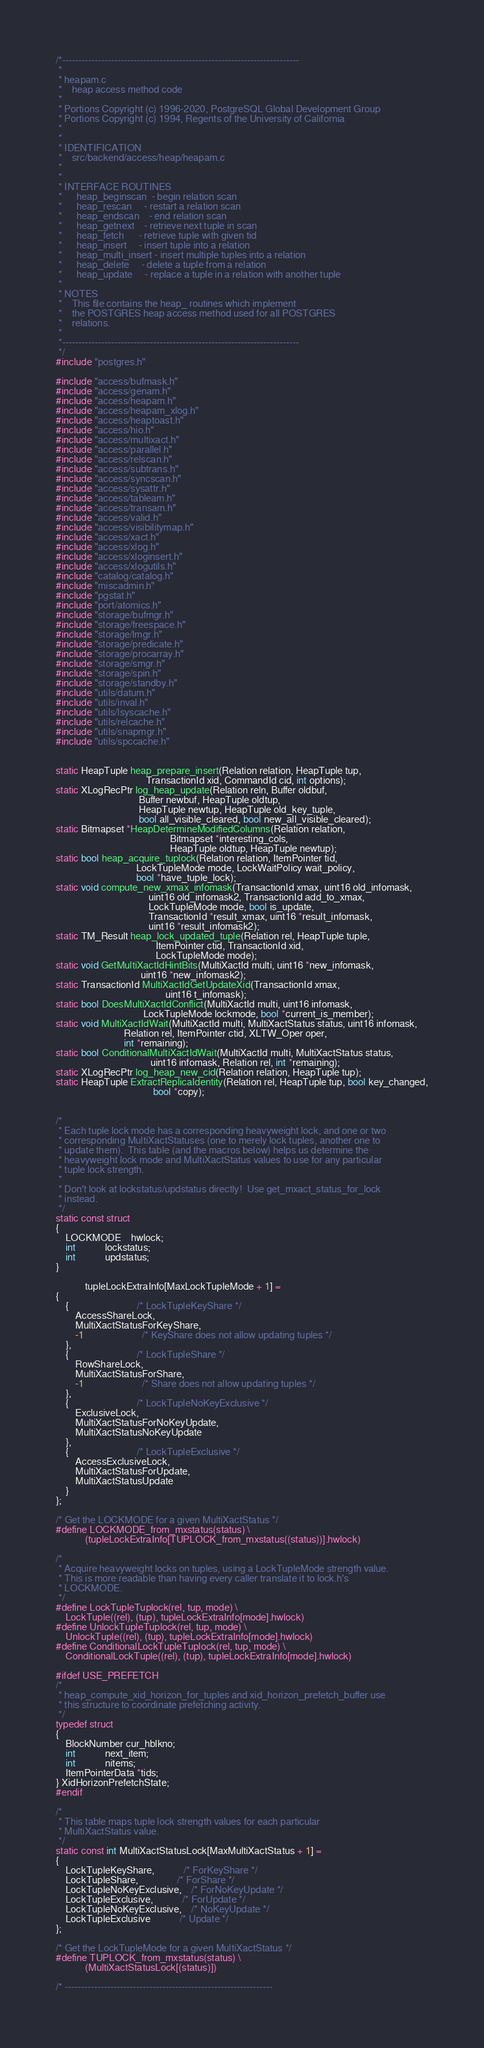<code> <loc_0><loc_0><loc_500><loc_500><_C_>/*-------------------------------------------------------------------------
 *
 * heapam.c
 *	  heap access method code
 *
 * Portions Copyright (c) 1996-2020, PostgreSQL Global Development Group
 * Portions Copyright (c) 1994, Regents of the University of California
 *
 *
 * IDENTIFICATION
 *	  src/backend/access/heap/heapam.c
 *
 *
 * INTERFACE ROUTINES
 *		heap_beginscan	- begin relation scan
 *		heap_rescan		- restart a relation scan
 *		heap_endscan	- end relation scan
 *		heap_getnext	- retrieve next tuple in scan
 *		heap_fetch		- retrieve tuple with given tid
 *		heap_insert		- insert tuple into a relation
 *		heap_multi_insert - insert multiple tuples into a relation
 *		heap_delete		- delete a tuple from a relation
 *		heap_update		- replace a tuple in a relation with another tuple
 *
 * NOTES
 *	  This file contains the heap_ routines which implement
 *	  the POSTGRES heap access method used for all POSTGRES
 *	  relations.
 *
 *-------------------------------------------------------------------------
 */
#include "postgres.h"

#include "access/bufmask.h"
#include "access/genam.h"
#include "access/heapam.h"
#include "access/heapam_xlog.h"
#include "access/heaptoast.h"
#include "access/hio.h"
#include "access/multixact.h"
#include "access/parallel.h"
#include "access/relscan.h"
#include "access/subtrans.h"
#include "access/syncscan.h"
#include "access/sysattr.h"
#include "access/tableam.h"
#include "access/transam.h"
#include "access/valid.h"
#include "access/visibilitymap.h"
#include "access/xact.h"
#include "access/xlog.h"
#include "access/xloginsert.h"
#include "access/xlogutils.h"
#include "catalog/catalog.h"
#include "miscadmin.h"
#include "pgstat.h"
#include "port/atomics.h"
#include "storage/bufmgr.h"
#include "storage/freespace.h"
#include "storage/lmgr.h"
#include "storage/predicate.h"
#include "storage/procarray.h"
#include "storage/smgr.h"
#include "storage/spin.h"
#include "storage/standby.h"
#include "utils/datum.h"
#include "utils/inval.h"
#include "utils/lsyscache.h"
#include "utils/relcache.h"
#include "utils/snapmgr.h"
#include "utils/spccache.h"


static HeapTuple heap_prepare_insert(Relation relation, HeapTuple tup,
									 TransactionId xid, CommandId cid, int options);
static XLogRecPtr log_heap_update(Relation reln, Buffer oldbuf,
								  Buffer newbuf, HeapTuple oldtup,
								  HeapTuple newtup, HeapTuple old_key_tuple,
								  bool all_visible_cleared, bool new_all_visible_cleared);
static Bitmapset *HeapDetermineModifiedColumns(Relation relation,
											   Bitmapset *interesting_cols,
											   HeapTuple oldtup, HeapTuple newtup);
static bool heap_acquire_tuplock(Relation relation, ItemPointer tid,
								 LockTupleMode mode, LockWaitPolicy wait_policy,
								 bool *have_tuple_lock);
static void compute_new_xmax_infomask(TransactionId xmax, uint16 old_infomask,
									  uint16 old_infomask2, TransactionId add_to_xmax,
									  LockTupleMode mode, bool is_update,
									  TransactionId *result_xmax, uint16 *result_infomask,
									  uint16 *result_infomask2);
static TM_Result heap_lock_updated_tuple(Relation rel, HeapTuple tuple,
										 ItemPointer ctid, TransactionId xid,
										 LockTupleMode mode);
static void GetMultiXactIdHintBits(MultiXactId multi, uint16 *new_infomask,
								   uint16 *new_infomask2);
static TransactionId MultiXactIdGetUpdateXid(TransactionId xmax,
											 uint16 t_infomask);
static bool DoesMultiXactIdConflict(MultiXactId multi, uint16 infomask,
									LockTupleMode lockmode, bool *current_is_member);
static void MultiXactIdWait(MultiXactId multi, MultiXactStatus status, uint16 infomask,
							Relation rel, ItemPointer ctid, XLTW_Oper oper,
							int *remaining);
static bool ConditionalMultiXactIdWait(MultiXactId multi, MultiXactStatus status,
									   uint16 infomask, Relation rel, int *remaining);
static XLogRecPtr log_heap_new_cid(Relation relation, HeapTuple tup);
static HeapTuple ExtractReplicaIdentity(Relation rel, HeapTuple tup, bool key_changed,
										bool *copy);


/*
 * Each tuple lock mode has a corresponding heavyweight lock, and one or two
 * corresponding MultiXactStatuses (one to merely lock tuples, another one to
 * update them).  This table (and the macros below) helps us determine the
 * heavyweight lock mode and MultiXactStatus values to use for any particular
 * tuple lock strength.
 *
 * Don't look at lockstatus/updstatus directly!  Use get_mxact_status_for_lock
 * instead.
 */
static const struct
{
	LOCKMODE	hwlock;
	int			lockstatus;
	int			updstatus;
}

			tupleLockExtraInfo[MaxLockTupleMode + 1] =
{
	{							/* LockTupleKeyShare */
		AccessShareLock,
		MultiXactStatusForKeyShare,
		-1						/* KeyShare does not allow updating tuples */
	},
	{							/* LockTupleShare */
		RowShareLock,
		MultiXactStatusForShare,
		-1						/* Share does not allow updating tuples */
	},
	{							/* LockTupleNoKeyExclusive */
		ExclusiveLock,
		MultiXactStatusForNoKeyUpdate,
		MultiXactStatusNoKeyUpdate
	},
	{							/* LockTupleExclusive */
		AccessExclusiveLock,
		MultiXactStatusForUpdate,
		MultiXactStatusUpdate
	}
};

/* Get the LOCKMODE for a given MultiXactStatus */
#define LOCKMODE_from_mxstatus(status) \
			(tupleLockExtraInfo[TUPLOCK_from_mxstatus((status))].hwlock)

/*
 * Acquire heavyweight locks on tuples, using a LockTupleMode strength value.
 * This is more readable than having every caller translate it to lock.h's
 * LOCKMODE.
 */
#define LockTupleTuplock(rel, tup, mode) \
	LockTuple((rel), (tup), tupleLockExtraInfo[mode].hwlock)
#define UnlockTupleTuplock(rel, tup, mode) \
	UnlockTuple((rel), (tup), tupleLockExtraInfo[mode].hwlock)
#define ConditionalLockTupleTuplock(rel, tup, mode) \
	ConditionalLockTuple((rel), (tup), tupleLockExtraInfo[mode].hwlock)

#ifdef USE_PREFETCH
/*
 * heap_compute_xid_horizon_for_tuples and xid_horizon_prefetch_buffer use
 * this structure to coordinate prefetching activity.
 */
typedef struct
{
	BlockNumber cur_hblkno;
	int			next_item;
	int			nitems;
	ItemPointerData *tids;
} XidHorizonPrefetchState;
#endif

/*
 * This table maps tuple lock strength values for each particular
 * MultiXactStatus value.
 */
static const int MultiXactStatusLock[MaxMultiXactStatus + 1] =
{
	LockTupleKeyShare,			/* ForKeyShare */
	LockTupleShare,				/* ForShare */
	LockTupleNoKeyExclusive,	/* ForNoKeyUpdate */
	LockTupleExclusive,			/* ForUpdate */
	LockTupleNoKeyExclusive,	/* NoKeyUpdate */
	LockTupleExclusive			/* Update */
};

/* Get the LockTupleMode for a given MultiXactStatus */
#define TUPLOCK_from_mxstatus(status) \
			(MultiXactStatusLock[(status)])

/* ----------------------------------------------------------------</code> 